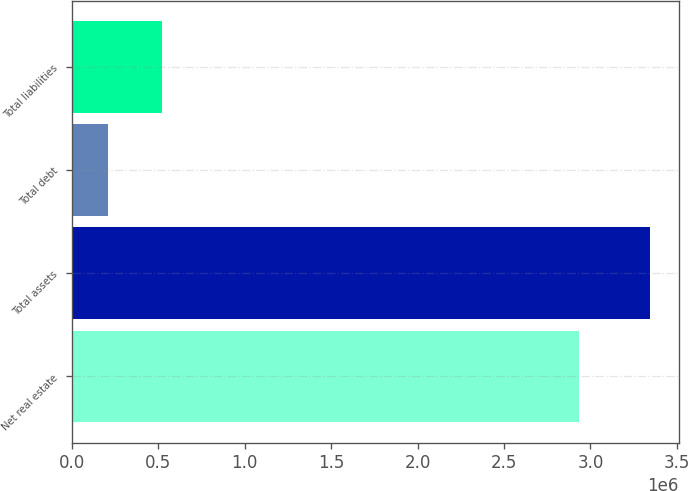Convert chart. <chart><loc_0><loc_0><loc_500><loc_500><bar_chart><fcel>Net real estate<fcel>Total assets<fcel>Total debt<fcel>Total liabilities<nl><fcel>2.9364e+06<fcel>3.34244e+06<fcel>210384<fcel>523590<nl></chart> 